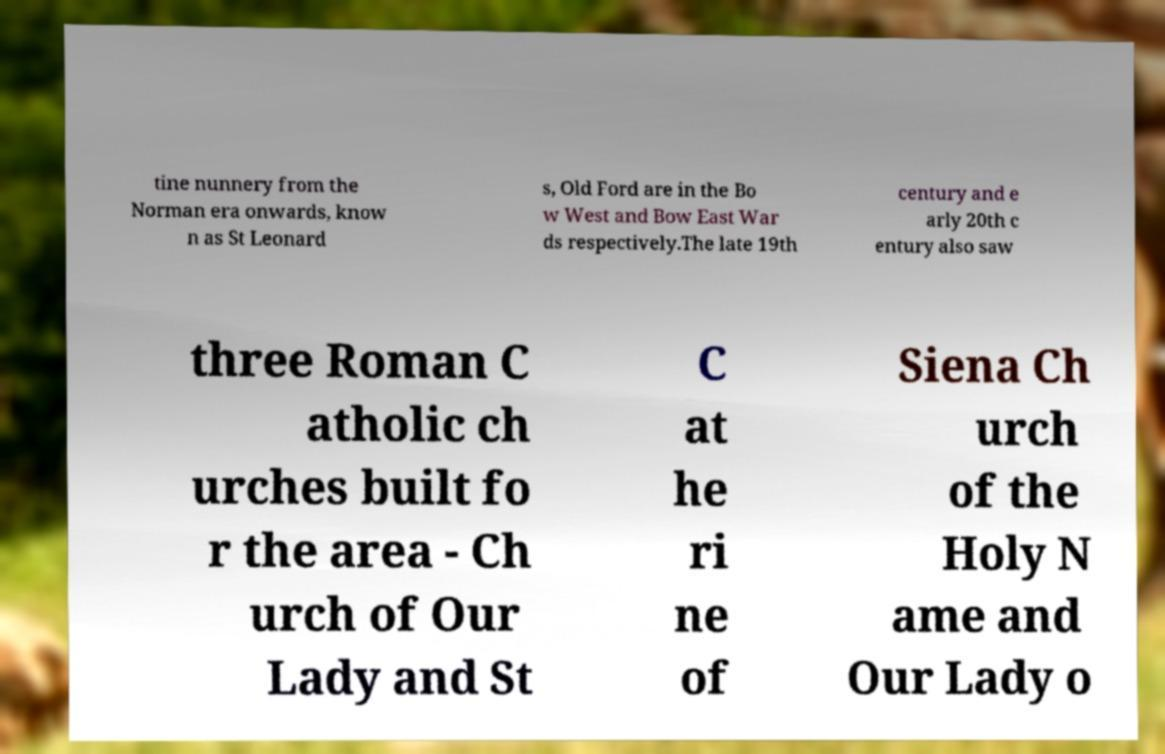Can you accurately transcribe the text from the provided image for me? tine nunnery from the Norman era onwards, know n as St Leonard s, Old Ford are in the Bo w West and Bow East War ds respectively.The late 19th century and e arly 20th c entury also saw three Roman C atholic ch urches built fo r the area - Ch urch of Our Lady and St C at he ri ne of Siena Ch urch of the Holy N ame and Our Lady o 